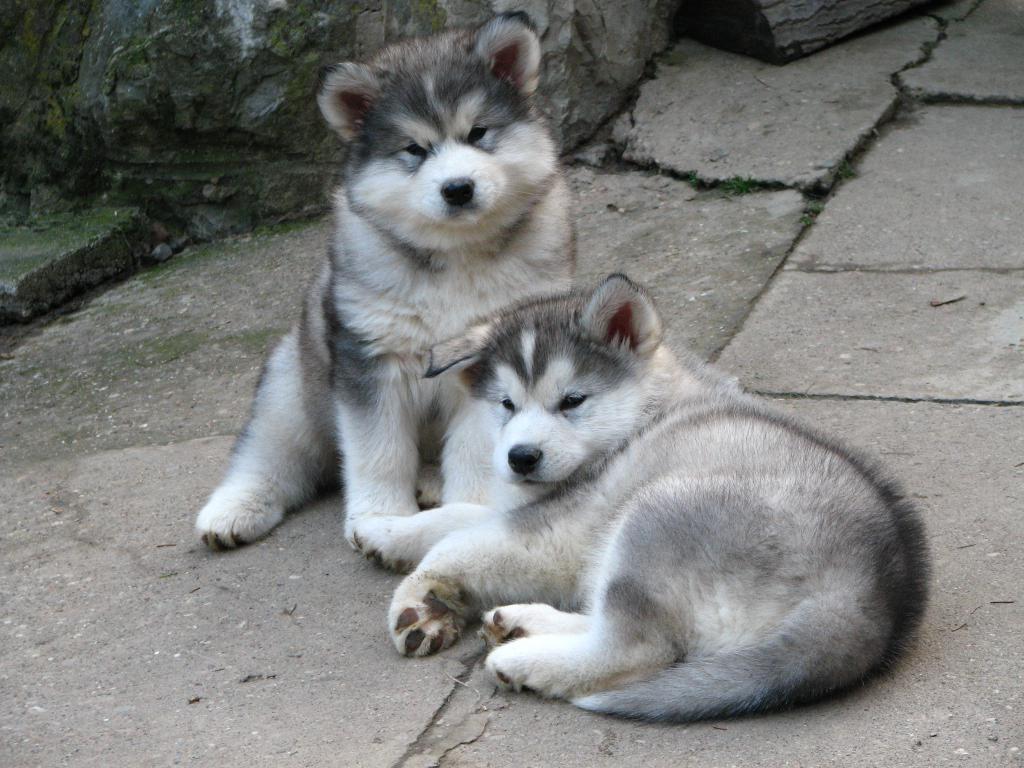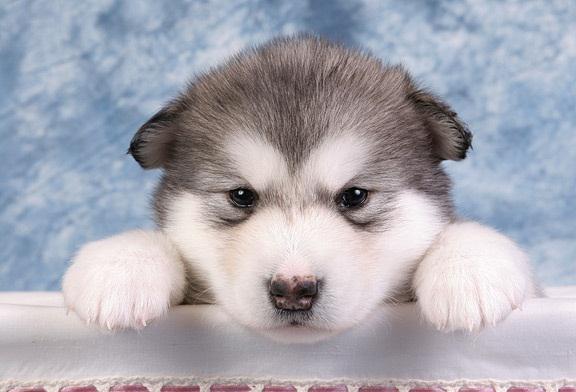The first image is the image on the left, the second image is the image on the right. For the images shown, is this caption "Exactly two dogs have their tongues out." true? Answer yes or no. No. 